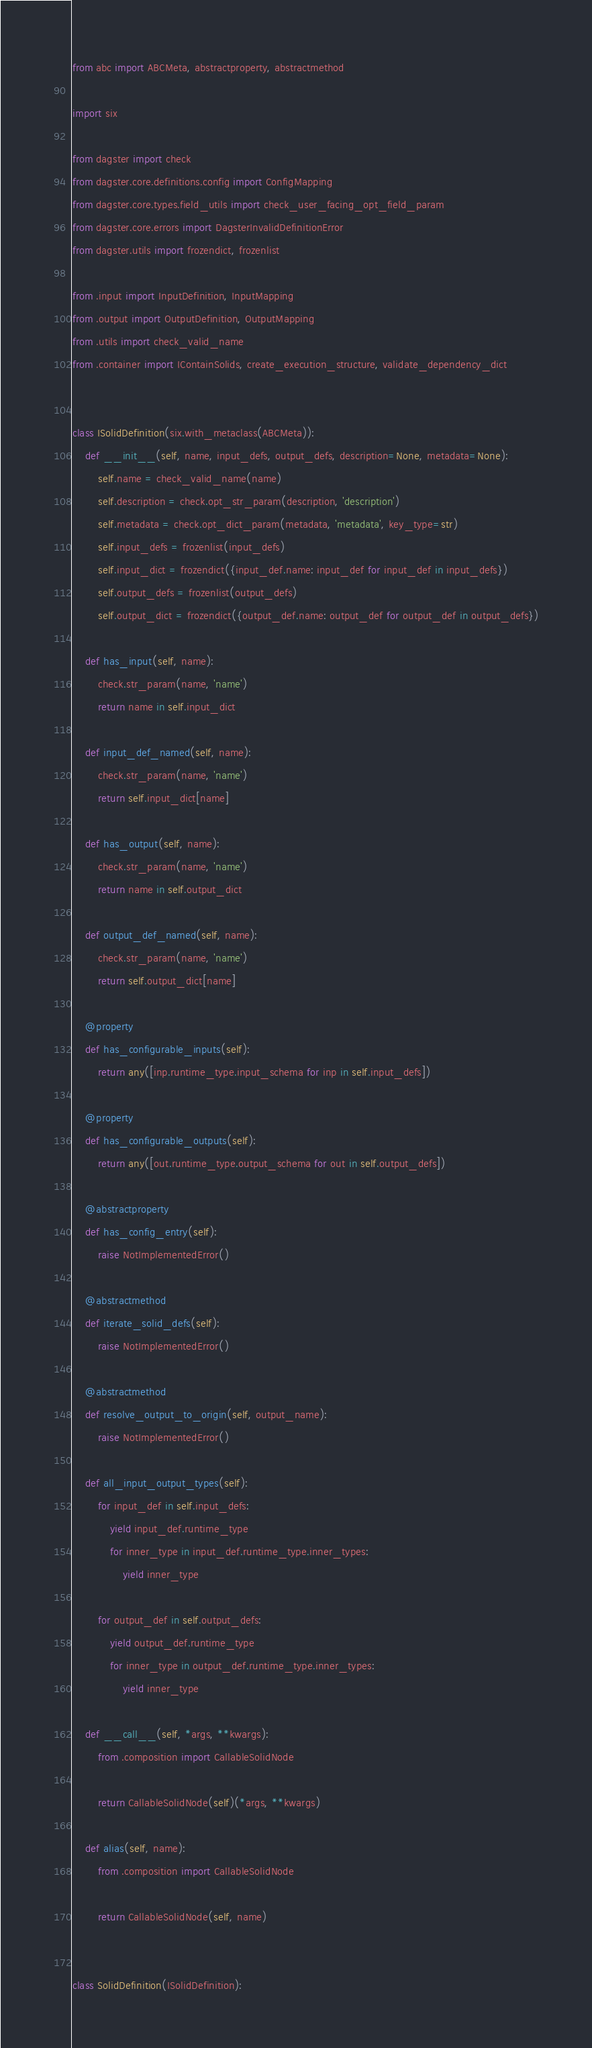<code> <loc_0><loc_0><loc_500><loc_500><_Python_>from abc import ABCMeta, abstractproperty, abstractmethod

import six

from dagster import check
from dagster.core.definitions.config import ConfigMapping
from dagster.core.types.field_utils import check_user_facing_opt_field_param
from dagster.core.errors import DagsterInvalidDefinitionError
from dagster.utils import frozendict, frozenlist

from .input import InputDefinition, InputMapping
from .output import OutputDefinition, OutputMapping
from .utils import check_valid_name
from .container import IContainSolids, create_execution_structure, validate_dependency_dict


class ISolidDefinition(six.with_metaclass(ABCMeta)):
    def __init__(self, name, input_defs, output_defs, description=None, metadata=None):
        self.name = check_valid_name(name)
        self.description = check.opt_str_param(description, 'description')
        self.metadata = check.opt_dict_param(metadata, 'metadata', key_type=str)
        self.input_defs = frozenlist(input_defs)
        self.input_dict = frozendict({input_def.name: input_def for input_def in input_defs})
        self.output_defs = frozenlist(output_defs)
        self.output_dict = frozendict({output_def.name: output_def for output_def in output_defs})

    def has_input(self, name):
        check.str_param(name, 'name')
        return name in self.input_dict

    def input_def_named(self, name):
        check.str_param(name, 'name')
        return self.input_dict[name]

    def has_output(self, name):
        check.str_param(name, 'name')
        return name in self.output_dict

    def output_def_named(self, name):
        check.str_param(name, 'name')
        return self.output_dict[name]

    @property
    def has_configurable_inputs(self):
        return any([inp.runtime_type.input_schema for inp in self.input_defs])

    @property
    def has_configurable_outputs(self):
        return any([out.runtime_type.output_schema for out in self.output_defs])

    @abstractproperty
    def has_config_entry(self):
        raise NotImplementedError()

    @abstractmethod
    def iterate_solid_defs(self):
        raise NotImplementedError()

    @abstractmethod
    def resolve_output_to_origin(self, output_name):
        raise NotImplementedError()

    def all_input_output_types(self):
        for input_def in self.input_defs:
            yield input_def.runtime_type
            for inner_type in input_def.runtime_type.inner_types:
                yield inner_type

        for output_def in self.output_defs:
            yield output_def.runtime_type
            for inner_type in output_def.runtime_type.inner_types:
                yield inner_type

    def __call__(self, *args, **kwargs):
        from .composition import CallableSolidNode

        return CallableSolidNode(self)(*args, **kwargs)

    def alias(self, name):
        from .composition import CallableSolidNode

        return CallableSolidNode(self, name)


class SolidDefinition(ISolidDefinition):</code> 